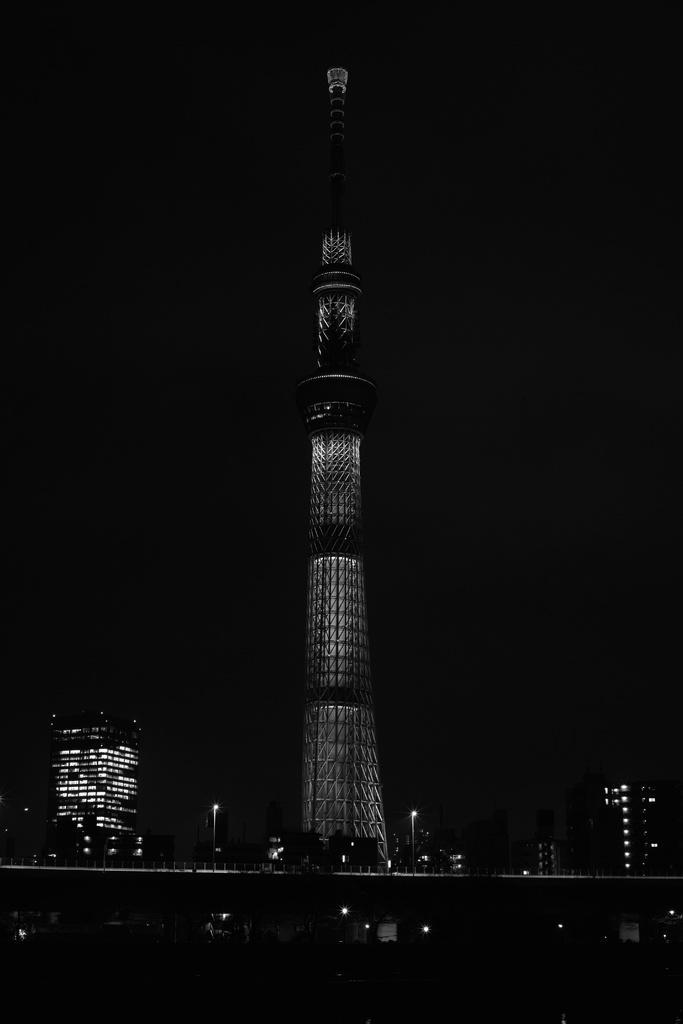In one or two sentences, can you explain what this image depicts? This is a black and white picture. There is a tall building. In the background there are other buildings. 